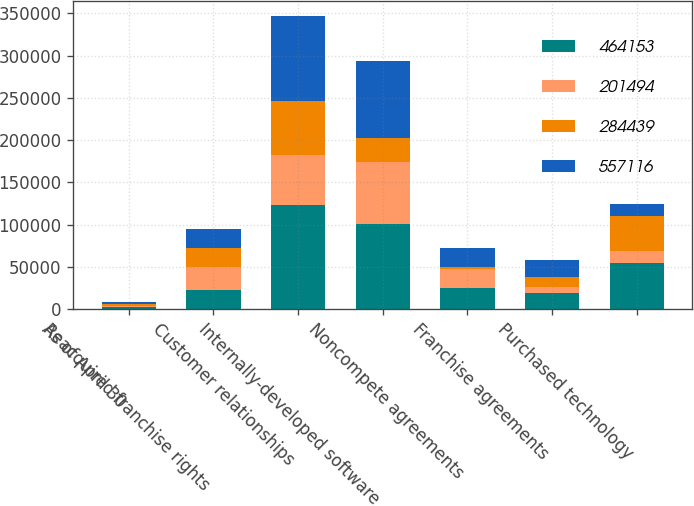<chart> <loc_0><loc_0><loc_500><loc_500><stacked_bar_chart><ecel><fcel>As of April 30<fcel>Reacquired franchise rights<fcel>Customer relationships<fcel>Internally-developed software<fcel>Noncompete agreements<fcel>Franchise agreements<fcel>Purchased technology<nl><fcel>464153<fcel>2014<fcel>23058<fcel>123110<fcel>101162<fcel>24694<fcel>19201<fcel>54900<nl><fcel>201494<fcel>2014<fcel>26136<fcel>59521<fcel>72598<fcel>22223<fcel>6934<fcel>13782<nl><fcel>284439<fcel>2014<fcel>23058<fcel>63589<fcel>28564<fcel>2471<fcel>12267<fcel>41118<nl><fcel>557116<fcel>2013<fcel>23058<fcel>100719<fcel>91745<fcel>23058<fcel>19201<fcel>14800<nl></chart> 